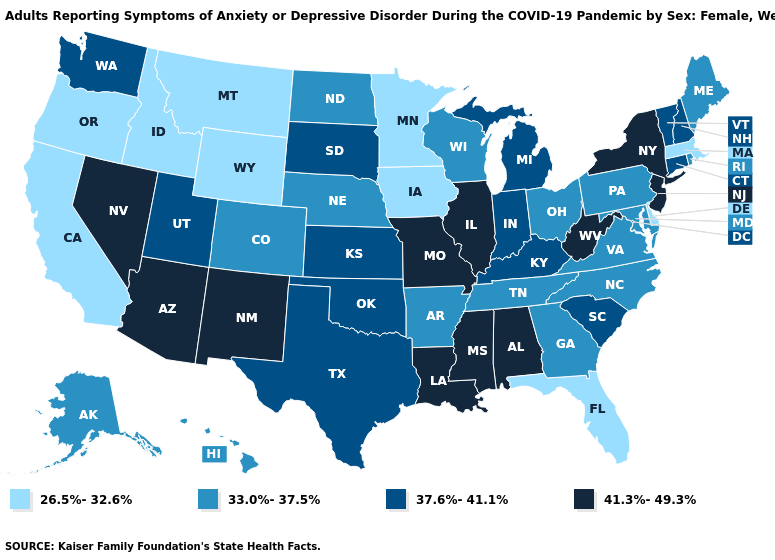What is the value of Connecticut?
Concise answer only. 37.6%-41.1%. What is the lowest value in states that border California?
Quick response, please. 26.5%-32.6%. Is the legend a continuous bar?
Short answer required. No. Name the states that have a value in the range 37.6%-41.1%?
Short answer required. Connecticut, Indiana, Kansas, Kentucky, Michigan, New Hampshire, Oklahoma, South Carolina, South Dakota, Texas, Utah, Vermont, Washington. Name the states that have a value in the range 37.6%-41.1%?
Answer briefly. Connecticut, Indiana, Kansas, Kentucky, Michigan, New Hampshire, Oklahoma, South Carolina, South Dakota, Texas, Utah, Vermont, Washington. What is the value of Wisconsin?
Give a very brief answer. 33.0%-37.5%. What is the lowest value in the USA?
Give a very brief answer. 26.5%-32.6%. Name the states that have a value in the range 26.5%-32.6%?
Concise answer only. California, Delaware, Florida, Idaho, Iowa, Massachusetts, Minnesota, Montana, Oregon, Wyoming. What is the value of Hawaii?
Keep it brief. 33.0%-37.5%. Name the states that have a value in the range 33.0%-37.5%?
Keep it brief. Alaska, Arkansas, Colorado, Georgia, Hawaii, Maine, Maryland, Nebraska, North Carolina, North Dakota, Ohio, Pennsylvania, Rhode Island, Tennessee, Virginia, Wisconsin. What is the value of Colorado?
Quick response, please. 33.0%-37.5%. What is the value of Texas?
Quick response, please. 37.6%-41.1%. What is the value of South Carolina?
Give a very brief answer. 37.6%-41.1%. Which states have the lowest value in the USA?
Answer briefly. California, Delaware, Florida, Idaho, Iowa, Massachusetts, Minnesota, Montana, Oregon, Wyoming. 